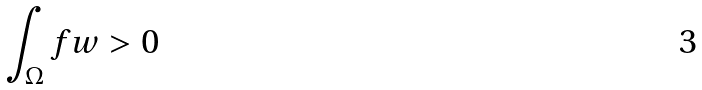<formula> <loc_0><loc_0><loc_500><loc_500>\int _ { \Omega } f w > 0</formula> 